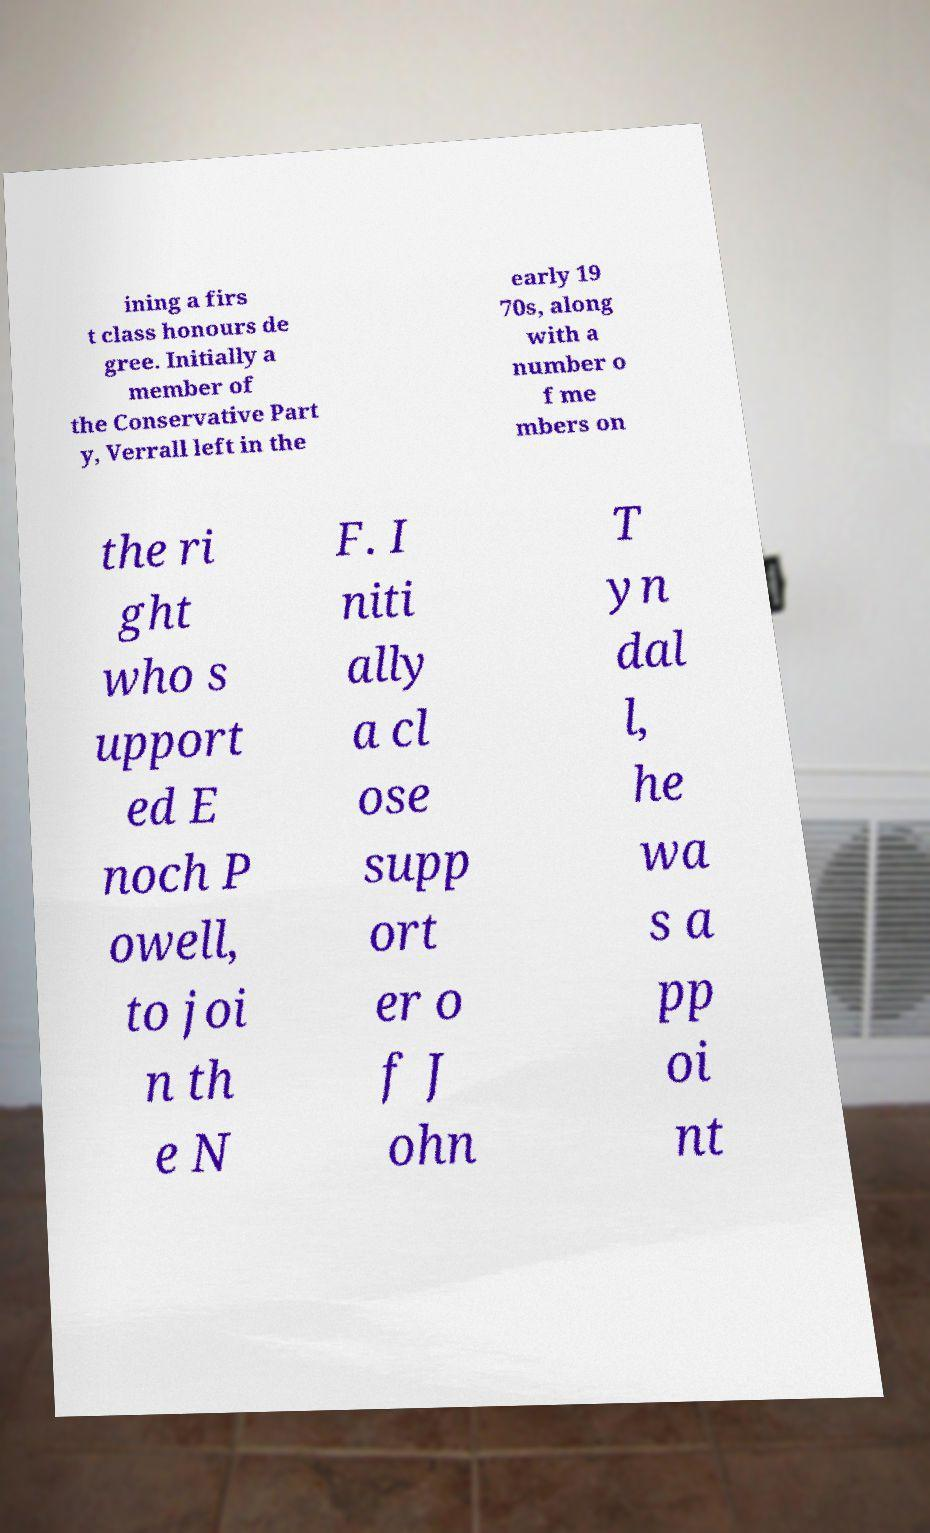Please read and relay the text visible in this image. What does it say? ining a firs t class honours de gree. Initially a member of the Conservative Part y, Verrall left in the early 19 70s, along with a number o f me mbers on the ri ght who s upport ed E noch P owell, to joi n th e N F. I niti ally a cl ose supp ort er o f J ohn T yn dal l, he wa s a pp oi nt 